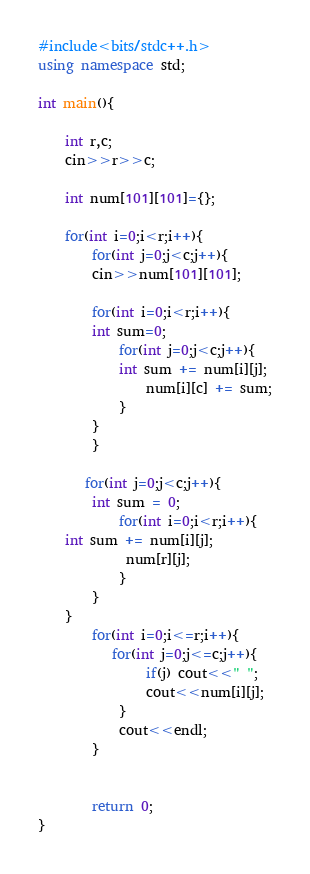<code> <loc_0><loc_0><loc_500><loc_500><_C++_>#include<bits/stdc++.h>
using namespace std;

int main(){
    
    int r,c;
    cin>>r>>c;
    
    int num[101][101]={};
    
    for(int i=0;i<r;i++){
        for(int j=0;j<c;j++){ 
        cin>>num[101][101];
        
        for(int i=0;i<r;i++){
        int sum=0;
            for(int j=0;j<c;j++){ 
            int sum += num[i][j];
                num[i][c] += sum;
            }
        }
        }
        
       for(int j=0;j<c;j++){ 
        int sum = 0;
            for(int i=0;i<r;i++){
    int sum += num[i][j];
             num[r][j];
            }
        }
    }
        for(int i=0;i<=r;i++){
           for(int j=0;j<=c;j++){
                if(j) cout<<" ";
                cout<<num[i][j];
            }
            cout<<endl;
        }
        
        
        return 0;
}
</code> 